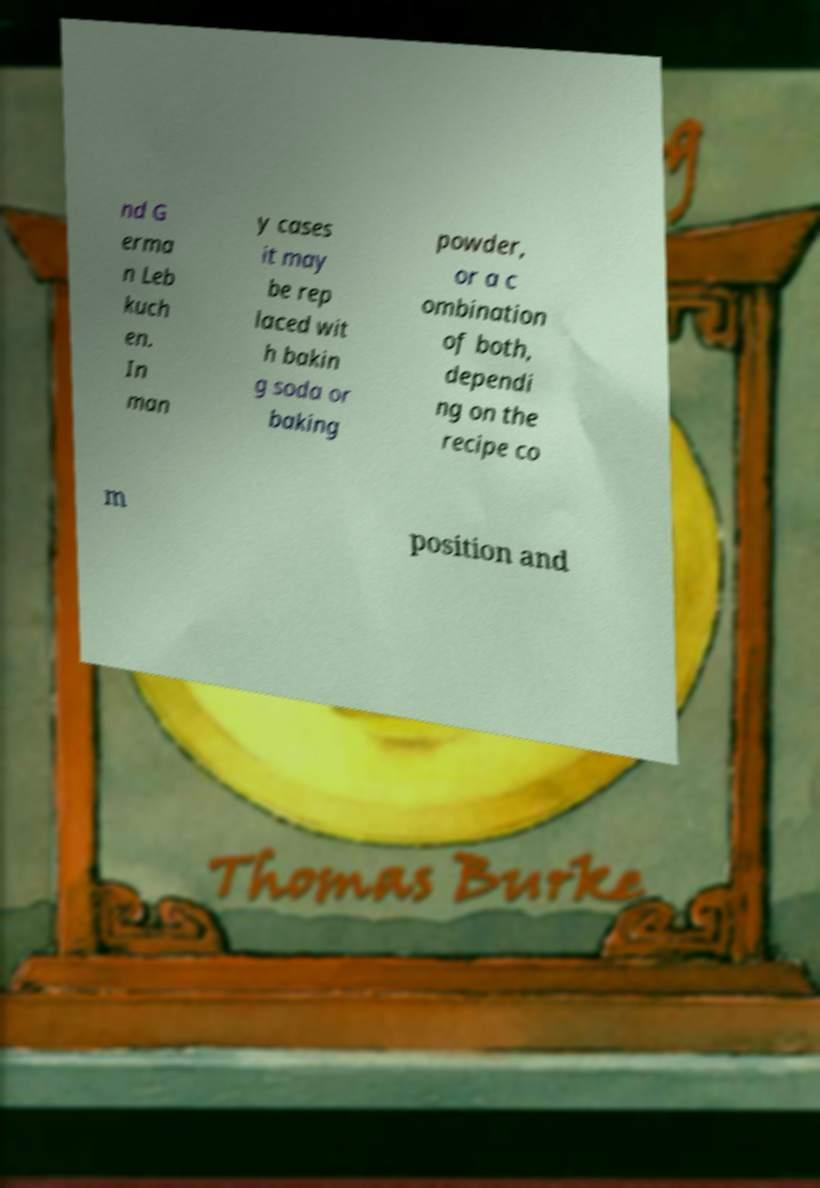For documentation purposes, I need the text within this image transcribed. Could you provide that? nd G erma n Leb kuch en. In man y cases it may be rep laced wit h bakin g soda or baking powder, or a c ombination of both, dependi ng on the recipe co m position and 